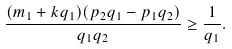Convert formula to latex. <formula><loc_0><loc_0><loc_500><loc_500>\frac { ( m _ { 1 } + k q _ { 1 } ) ( p _ { 2 } q _ { 1 } - p _ { 1 } q _ { 2 } ) } { q _ { 1 } q _ { 2 } } \geq \frac { 1 } { q _ { 1 } } .</formula> 